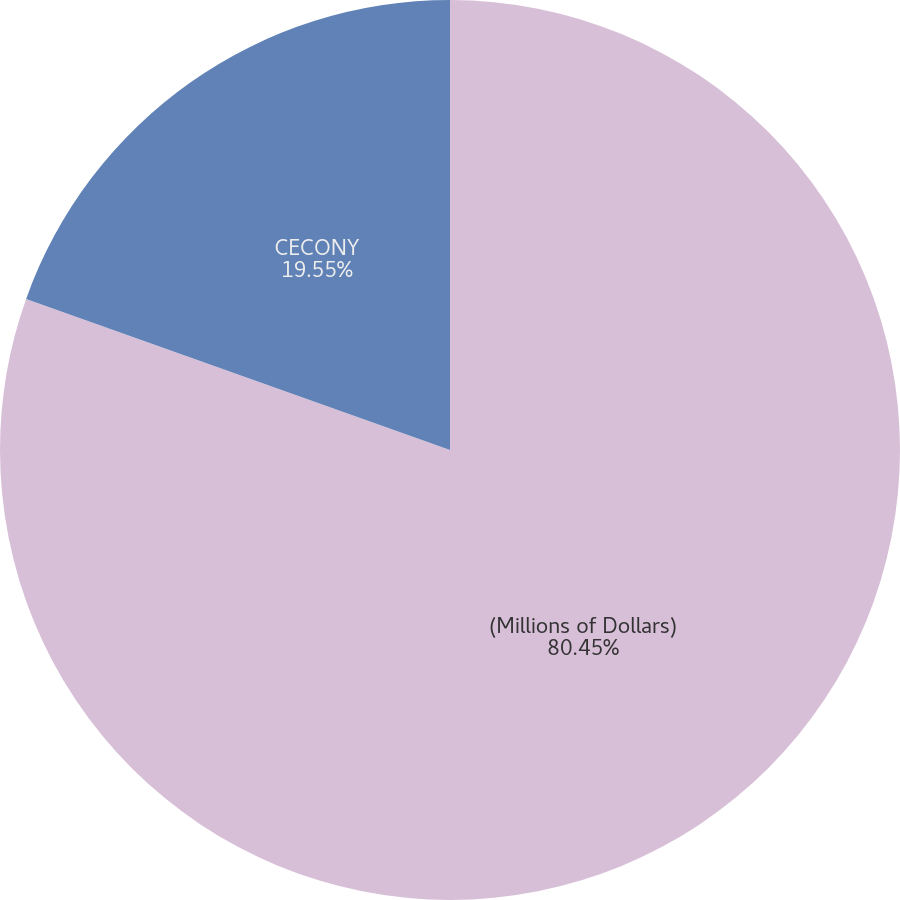Convert chart. <chart><loc_0><loc_0><loc_500><loc_500><pie_chart><fcel>(Millions of Dollars)<fcel>CECONY<nl><fcel>80.45%<fcel>19.55%<nl></chart> 